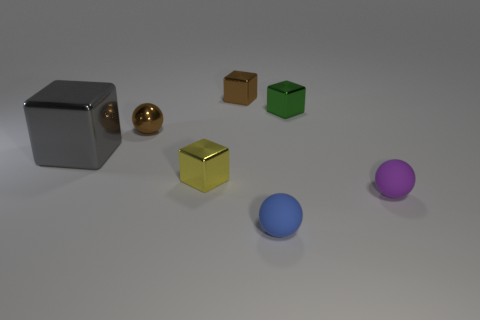Subtract all gray spheres. Subtract all green cylinders. How many spheres are left? 3 Add 1 tiny cyan rubber objects. How many objects exist? 8 Subtract all cubes. How many objects are left? 3 Add 7 tiny green metallic things. How many tiny green metallic things are left? 8 Add 1 big metallic objects. How many big metallic objects exist? 2 Subtract 0 cyan blocks. How many objects are left? 7 Subtract all spheres. Subtract all small brown shiny cubes. How many objects are left? 3 